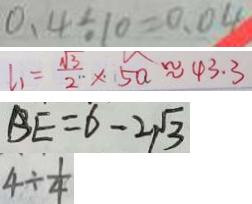<formula> <loc_0><loc_0><loc_500><loc_500>0 . 4 \div 1 0 = 0 . 0 4 
 l _ { 1 } = \frac { \sqrt { 3 } } { 2 } \times 5 a \approx 4 3 . 3 
 B E = 6 - 2 \sqrt { 3 } 
 4 \div \frac { 1 } { 4 }</formula> 